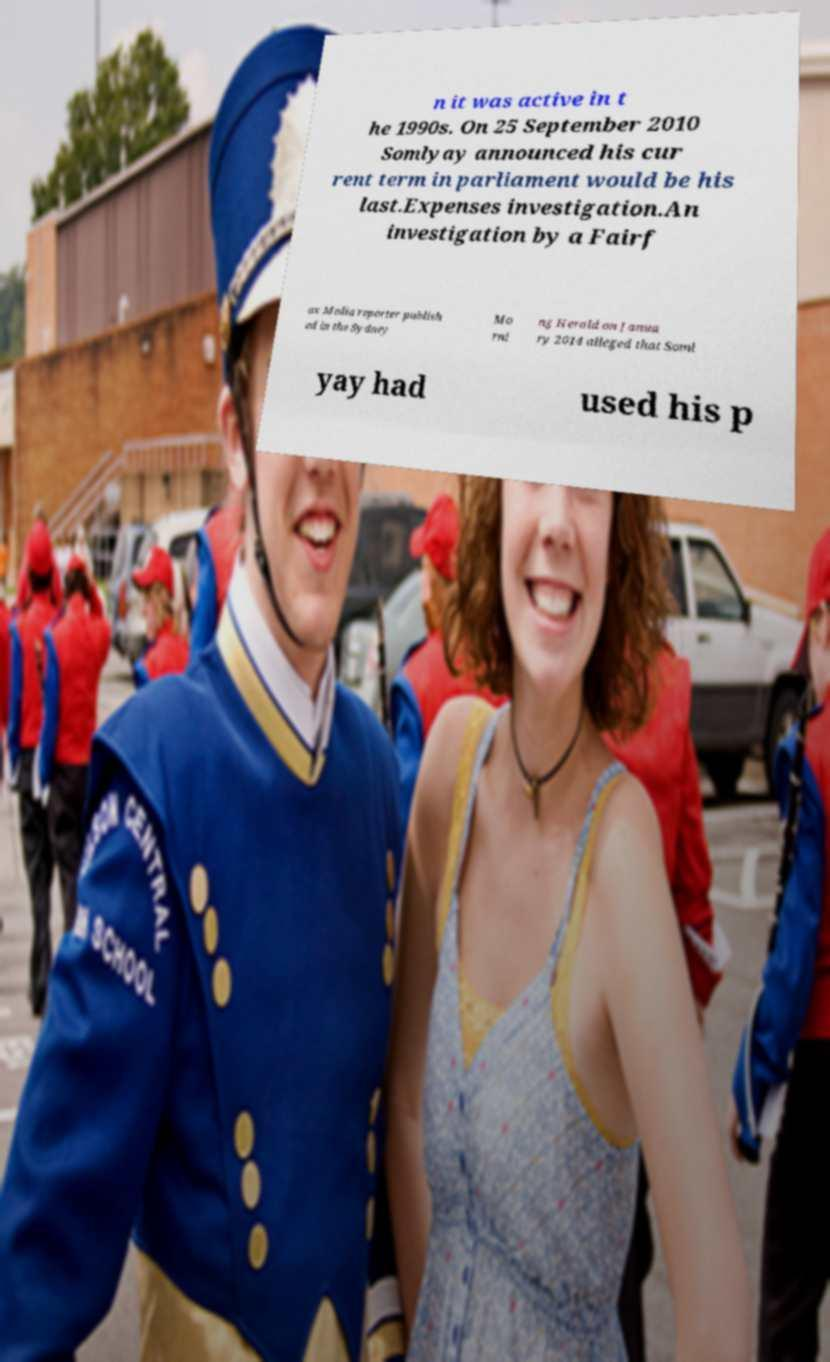Could you assist in decoding the text presented in this image and type it out clearly? n it was active in t he 1990s. On 25 September 2010 Somlyay announced his cur rent term in parliament would be his last.Expenses investigation.An investigation by a Fairf ax Media reporter publish ed in the Sydney Mo rni ng Herald on Janua ry 2014 alleged that Soml yay had used his p 